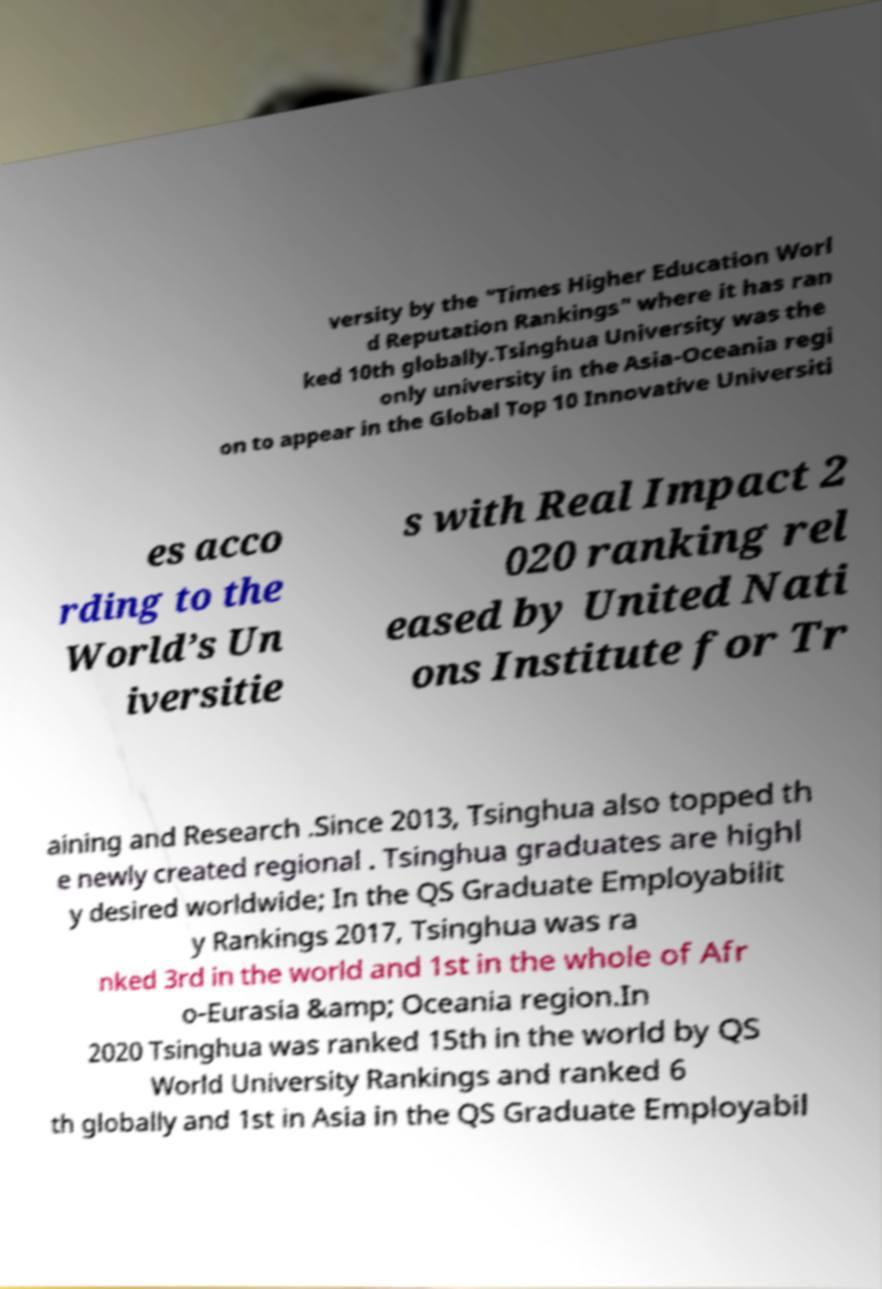What messages or text are displayed in this image? I need them in a readable, typed format. versity by the "Times Higher Education Worl d Reputation Rankings" where it has ran ked 10th globally.Tsinghua University was the only university in the Asia-Oceania regi on to appear in the Global Top 10 Innovative Universiti es acco rding to the World’s Un iversitie s with Real Impact 2 020 ranking rel eased by United Nati ons Institute for Tr aining and Research .Since 2013, Tsinghua also topped th e newly created regional . Tsinghua graduates are highl y desired worldwide; In the QS Graduate Employabilit y Rankings 2017, Tsinghua was ra nked 3rd in the world and 1st in the whole of Afr o-Eurasia &amp; Oceania region.In 2020 Tsinghua was ranked 15th in the world by QS World University Rankings and ranked 6 th globally and 1st in Asia in the QS Graduate Employabil 